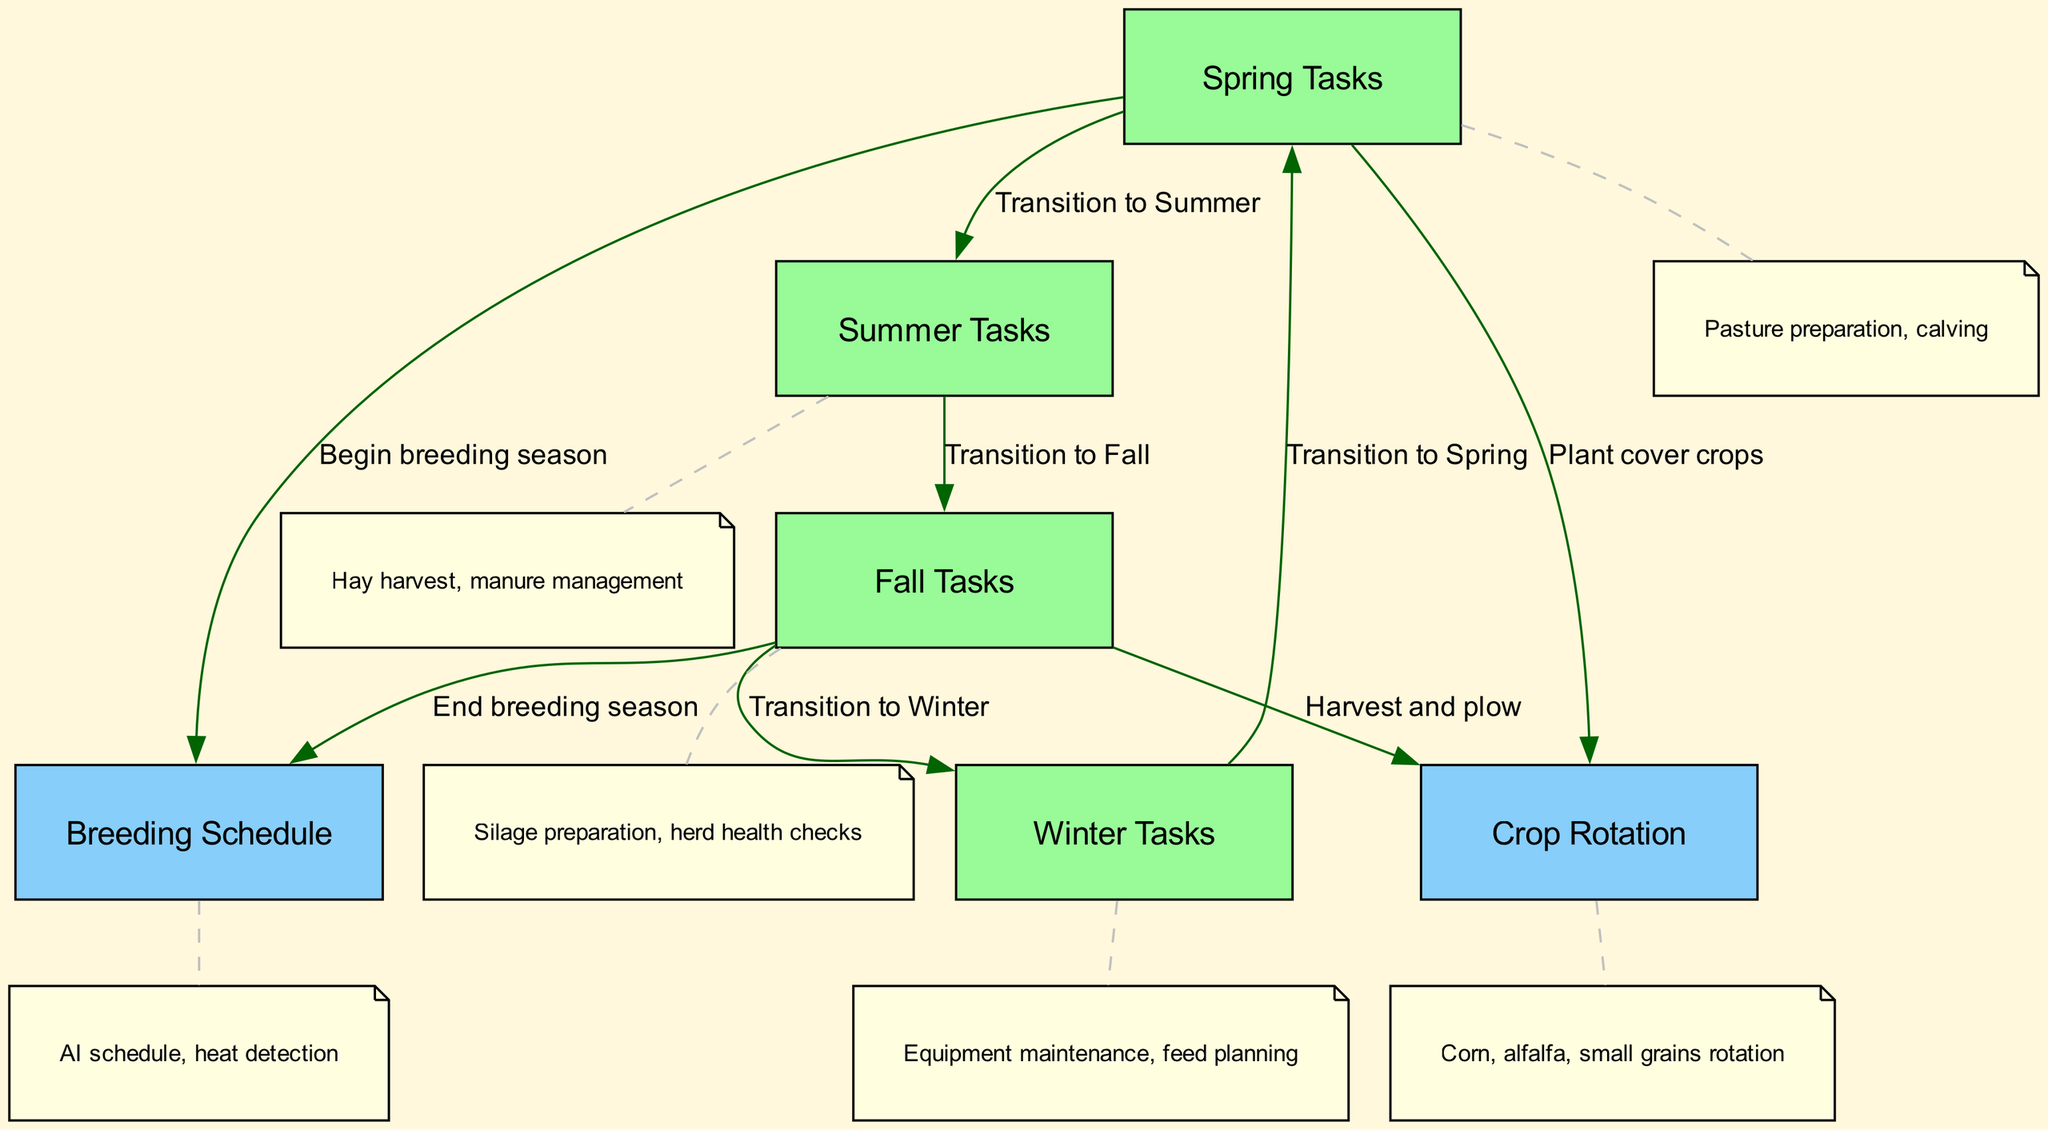What are the seasonal tasks for summer? The diagram indicates that summer tasks involve hay harvest and manure management. These activities are listed under the summer node, making it clear they are the focus for that season.
Answer: Hay harvest, manure management How many edges are there in the diagram? By counting the connections (edges) between the nodes, we see that there are eight edges connecting the various tasks and schedules in the cycle.
Answer: 8 What season does the breeding schedule start? Analyzing the diagram, we can see that the breeding schedule begins in the spring, as this is specified under the arrow connecting spring to breeding.
Answer: Spring What is the primary task during the fall? The diagram specifies that the primary tasks during the fall include silage preparation and herd health checks, which are noted under the fall node.
Answer: Silage preparation, herd health checks What transitions from fall to winter? The diagram shows a direct transition labeled "Transition to Winter," indicating that the flow of management tasks goes from fall to winter.
Answer: Transition to Winter Which crops are included in the crop rotation? The crop rotation node identifies corn, alfalfa, and small grains as the crops involved in the rotation, as indicated in the annotation connecting to that node.
Answer: Corn, alfalfa, small grains How many tasks are listed for winter? By examining the winter node in the diagram, we find that it is associated with two tasks: equipment maintenance and feed planning, thus there are two tasks listed.
Answer: 2 What is the last step before the spring tasks? According to the diagram, the last step before returning to spring tasks is the transition from winter, as indicated by the directed edge connecting winter back to spring.
Answer: Transition to Spring 